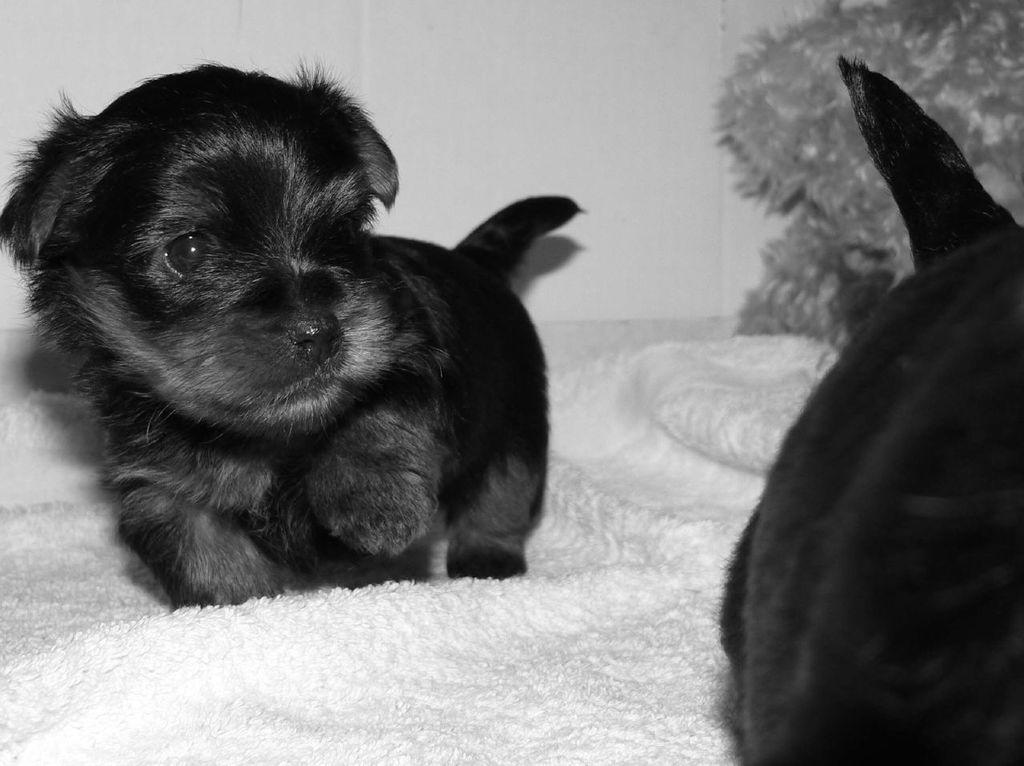What is the color scheme of the image? The image is black and white. What animals are present on a surface in the image? There are puppies on a cloth surface in the image. What is visible in the background of the image? The background of the image includes a white wall. What type of stove can be seen in the image? There is no stove present in the image. What team is the puppy supporting in the image? The image does not depict any sports teams or affiliations. 